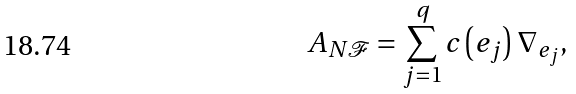Convert formula to latex. <formula><loc_0><loc_0><loc_500><loc_500>A _ { N \mathcal { F } } = \sum _ { j = 1 } ^ { q } c \left ( e _ { j } \right ) \nabla _ { e _ { j } } ,</formula> 